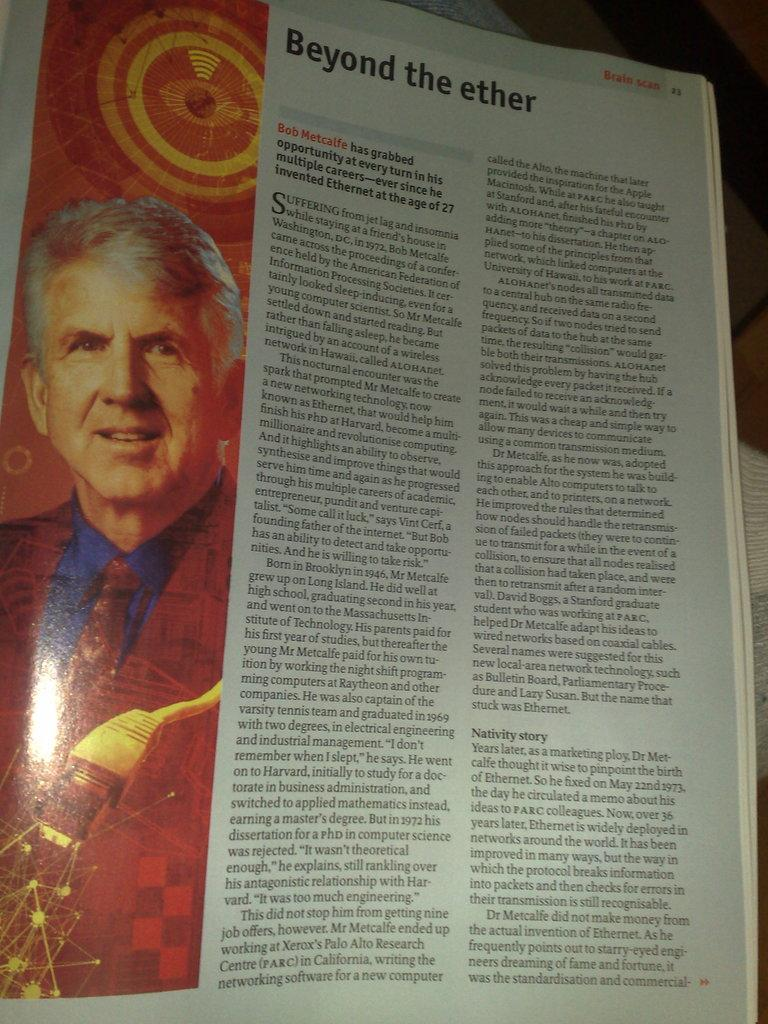What is the main object in the image? There is a book in the image. What can be seen on one of the pages of the book? The book has a page with an image of a person. Is there any text on the page with the person's image? Yes, there is text on the page. What type of cast can be seen on the person's arm in the image? There is no cast visible on the person's arm in the image, as the image only shows a person on a page of the book. 